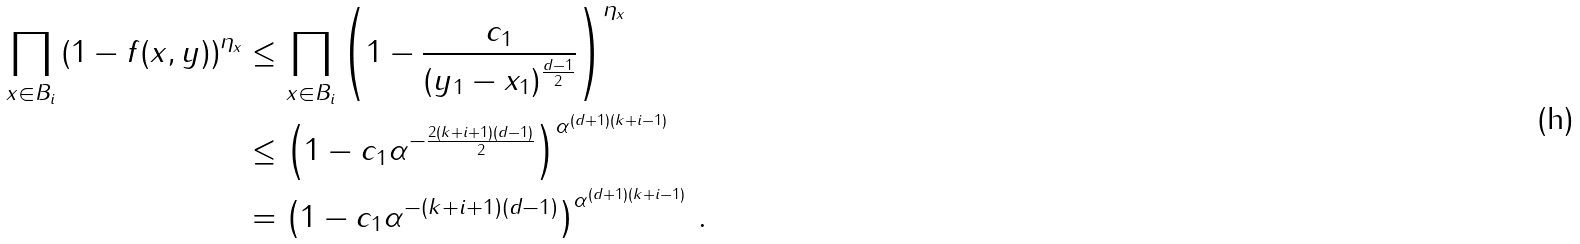Convert formula to latex. <formula><loc_0><loc_0><loc_500><loc_500>\prod _ { x \in B _ { i } } \left ( 1 - f ( x , y ) \right ) ^ { \eta _ { x } } & \leq \prod _ { x \in B _ { i } } \left ( 1 - \frac { c _ { 1 } } { ( y _ { 1 } - x _ { 1 } ) ^ { \frac { d - 1 } { 2 } } } \right ) ^ { \eta _ { x } } \\ & \leq \left ( 1 - c _ { 1 } \alpha ^ { - \frac { 2 ( k + i + 1 ) ( d - 1 ) } { 2 } } \right ) ^ { \alpha ^ { ( d + 1 ) ( k + i - 1 ) } } \\ & = \left ( 1 - c _ { 1 } \alpha ^ { - ( k + i + 1 ) ( d - 1 ) } \right ) ^ { \alpha ^ { ( d + 1 ) ( k + i - 1 ) } } \, .</formula> 